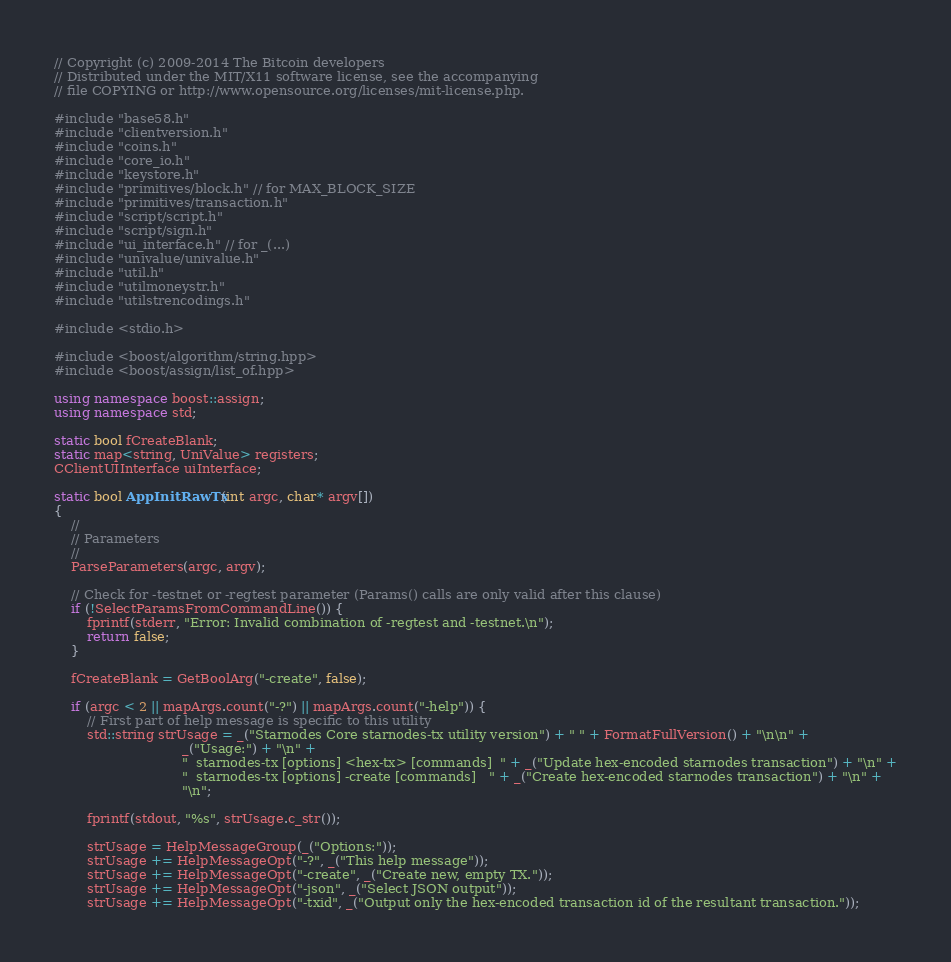Convert code to text. <code><loc_0><loc_0><loc_500><loc_500><_C++_>// Copyright (c) 2009-2014 The Bitcoin developers
// Distributed under the MIT/X11 software license, see the accompanying
// file COPYING or http://www.opensource.org/licenses/mit-license.php.

#include "base58.h"
#include "clientversion.h"
#include "coins.h"
#include "core_io.h"
#include "keystore.h"
#include "primitives/block.h" // for MAX_BLOCK_SIZE
#include "primitives/transaction.h"
#include "script/script.h"
#include "script/sign.h"
#include "ui_interface.h" // for _(...)
#include "univalue/univalue.h"
#include "util.h"
#include "utilmoneystr.h"
#include "utilstrencodings.h"

#include <stdio.h>

#include <boost/algorithm/string.hpp>
#include <boost/assign/list_of.hpp>

using namespace boost::assign;
using namespace std;

static bool fCreateBlank;
static map<string, UniValue> registers;
CClientUIInterface uiInterface;

static bool AppInitRawTx(int argc, char* argv[])
{
    //
    // Parameters
    //
    ParseParameters(argc, argv);

    // Check for -testnet or -regtest parameter (Params() calls are only valid after this clause)
    if (!SelectParamsFromCommandLine()) {
        fprintf(stderr, "Error: Invalid combination of -regtest and -testnet.\n");
        return false;
    }

    fCreateBlank = GetBoolArg("-create", false);

    if (argc < 2 || mapArgs.count("-?") || mapArgs.count("-help")) {
        // First part of help message is specific to this utility
        std::string strUsage = _("Starnodes Core starnodes-tx utility version") + " " + FormatFullVersion() + "\n\n" +
                               _("Usage:") + "\n" +
                               "  starnodes-tx [options] <hex-tx> [commands]  " + _("Update hex-encoded starnodes transaction") + "\n" +
                               "  starnodes-tx [options] -create [commands]   " + _("Create hex-encoded starnodes transaction") + "\n" +
                               "\n";

        fprintf(stdout, "%s", strUsage.c_str());

        strUsage = HelpMessageGroup(_("Options:"));
        strUsage += HelpMessageOpt("-?", _("This help message"));
        strUsage += HelpMessageOpt("-create", _("Create new, empty TX."));
        strUsage += HelpMessageOpt("-json", _("Select JSON output"));
        strUsage += HelpMessageOpt("-txid", _("Output only the hex-encoded transaction id of the resultant transaction."));</code> 